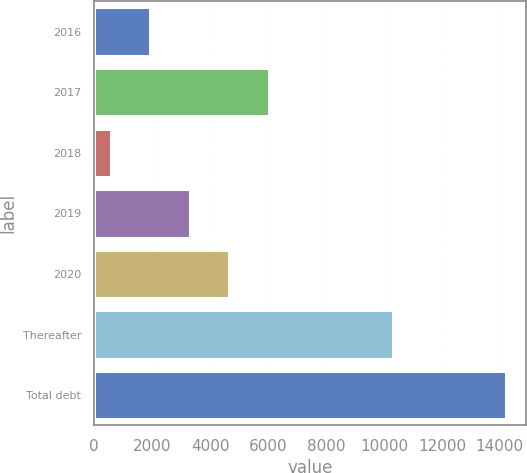Convert chart. <chart><loc_0><loc_0><loc_500><loc_500><bar_chart><fcel>2016<fcel>2017<fcel>2018<fcel>2019<fcel>2020<fcel>Thereafter<fcel>Total debt<nl><fcel>1929.5<fcel>6020<fcel>566<fcel>3293<fcel>4656.5<fcel>10318<fcel>14201<nl></chart> 